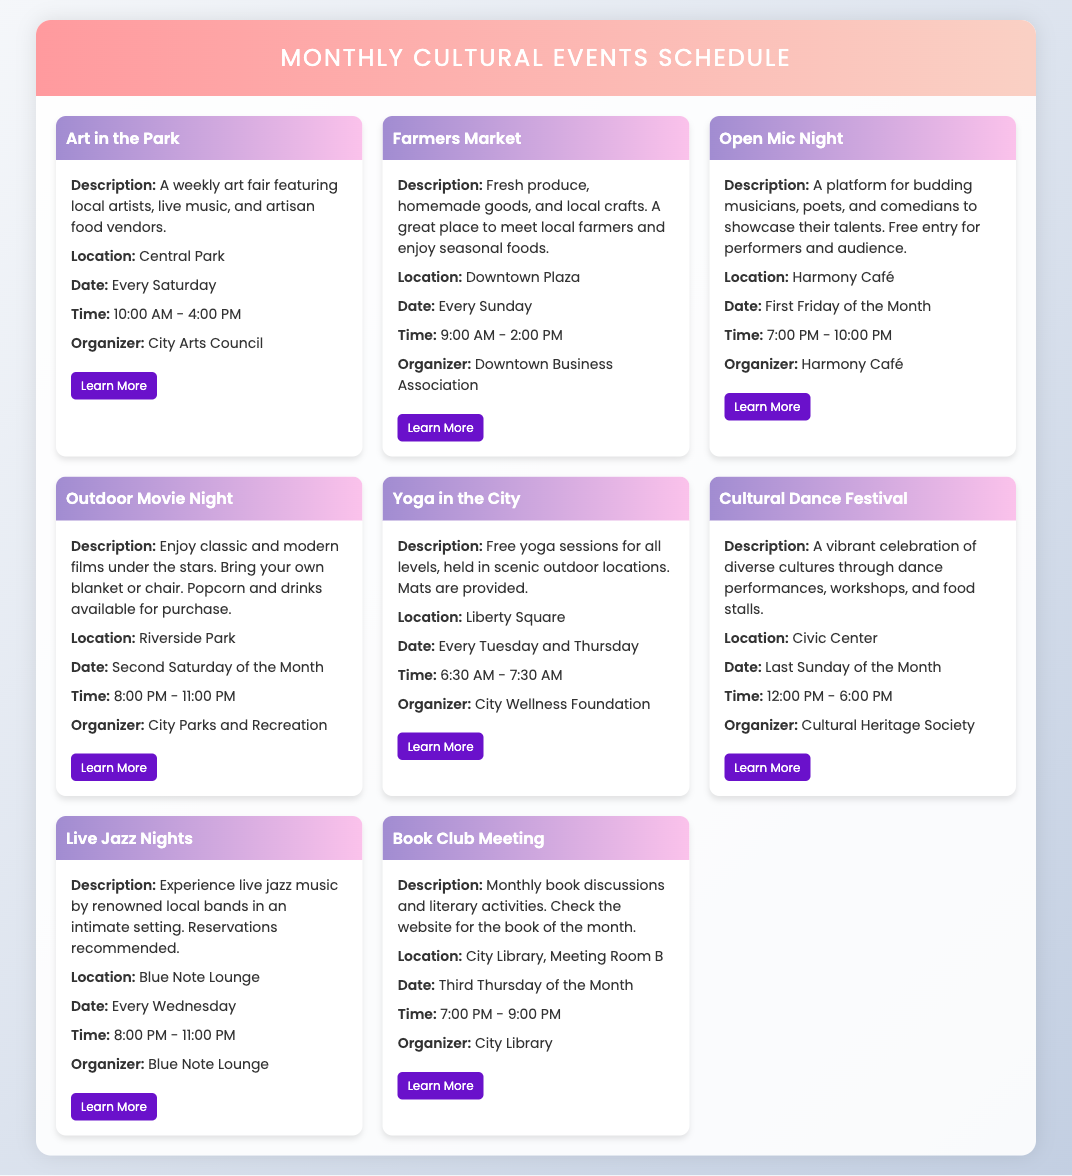what is the location of the Art in the Park event? The location of the Art in the Park event is provided in the event details, which indicates it takes place in Central Park.
Answer: Central Park when is the Farmers Market held? The document states that the Farmers Market is held every Sunday.
Answer: Every Sunday what time does the Outdoor Movie Night start? The event details specify that the Outdoor Movie Night starts at 8:00 PM.
Answer: 8:00 PM who organizes the Yoga in the City sessions? The organizer of the Yoga in the City sessions is mentioned as the City Wellness Foundation.
Answer: City Wellness Foundation how frequently does the Cultural Dance Festival occur? The document indicates that the Cultural Dance Festival occurs once a month, specifically on the last Sunday.
Answer: Once a month what type of performances can be seen at Open Mic Night? The description of Open Mic Night mentions that it features budding musicians, poets, and comedians.
Answer: Musicians, poets, and comedians what is required for attendees at the Outdoor Movie Night? The details state that attendees should bring their own blanket or chair.
Answer: Blanket or chair which event occurs on the first Friday of the month? The document specifies that Open Mic Night takes place on the first Friday of the month.
Answer: Open Mic Night is there a cost to perform at the Open Mic Night? The document mentions that there is free entry for performers at the Open Mic Night.
Answer: Free entry 